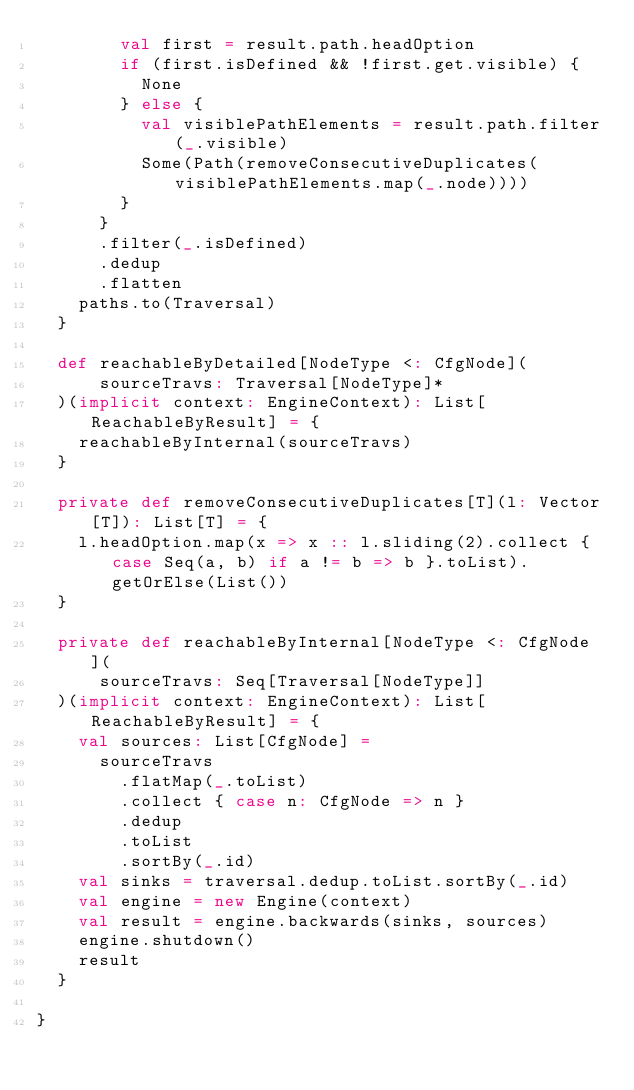Convert code to text. <code><loc_0><loc_0><loc_500><loc_500><_Scala_>        val first = result.path.headOption
        if (first.isDefined && !first.get.visible) {
          None
        } else {
          val visiblePathElements = result.path.filter(_.visible)
          Some(Path(removeConsecutiveDuplicates(visiblePathElements.map(_.node))))
        }
      }
      .filter(_.isDefined)
      .dedup
      .flatten
    paths.to(Traversal)
  }

  def reachableByDetailed[NodeType <: CfgNode](
      sourceTravs: Traversal[NodeType]*
  )(implicit context: EngineContext): List[ReachableByResult] = {
    reachableByInternal(sourceTravs)
  }

  private def removeConsecutiveDuplicates[T](l: Vector[T]): List[T] = {
    l.headOption.map(x => x :: l.sliding(2).collect { case Seq(a, b) if a != b => b }.toList).getOrElse(List())
  }

  private def reachableByInternal[NodeType <: CfgNode](
      sourceTravs: Seq[Traversal[NodeType]]
  )(implicit context: EngineContext): List[ReachableByResult] = {
    val sources: List[CfgNode] =
      sourceTravs
        .flatMap(_.toList)
        .collect { case n: CfgNode => n }
        .dedup
        .toList
        .sortBy(_.id)
    val sinks = traversal.dedup.toList.sortBy(_.id)
    val engine = new Engine(context)
    val result = engine.backwards(sinks, sources)
    engine.shutdown()
    result
  }

}
</code> 